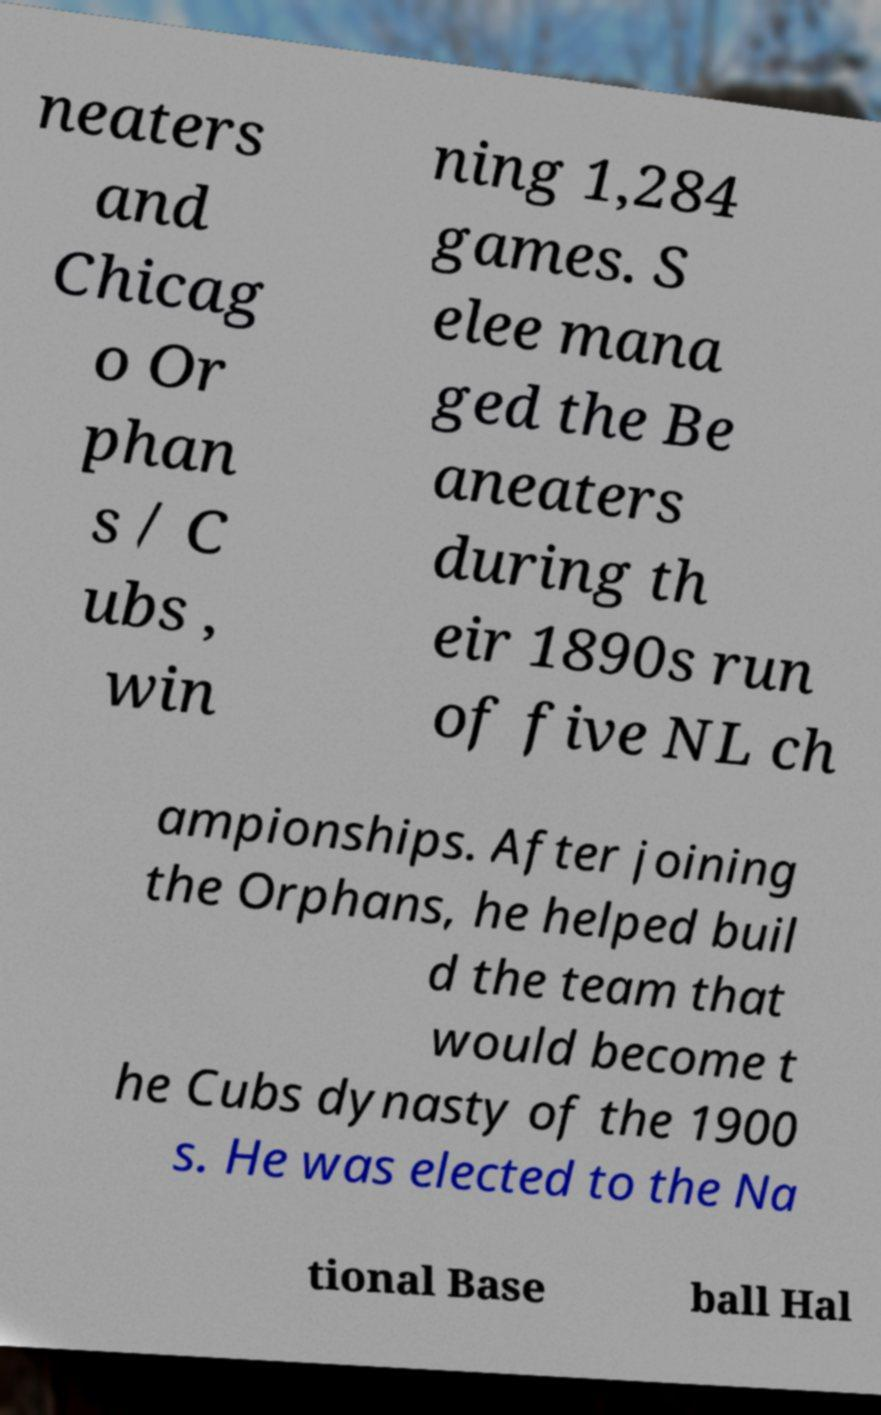Could you assist in decoding the text presented in this image and type it out clearly? neaters and Chicag o Or phan s / C ubs , win ning 1,284 games. S elee mana ged the Be aneaters during th eir 1890s run of five NL ch ampionships. After joining the Orphans, he helped buil d the team that would become t he Cubs dynasty of the 1900 s. He was elected to the Na tional Base ball Hal 